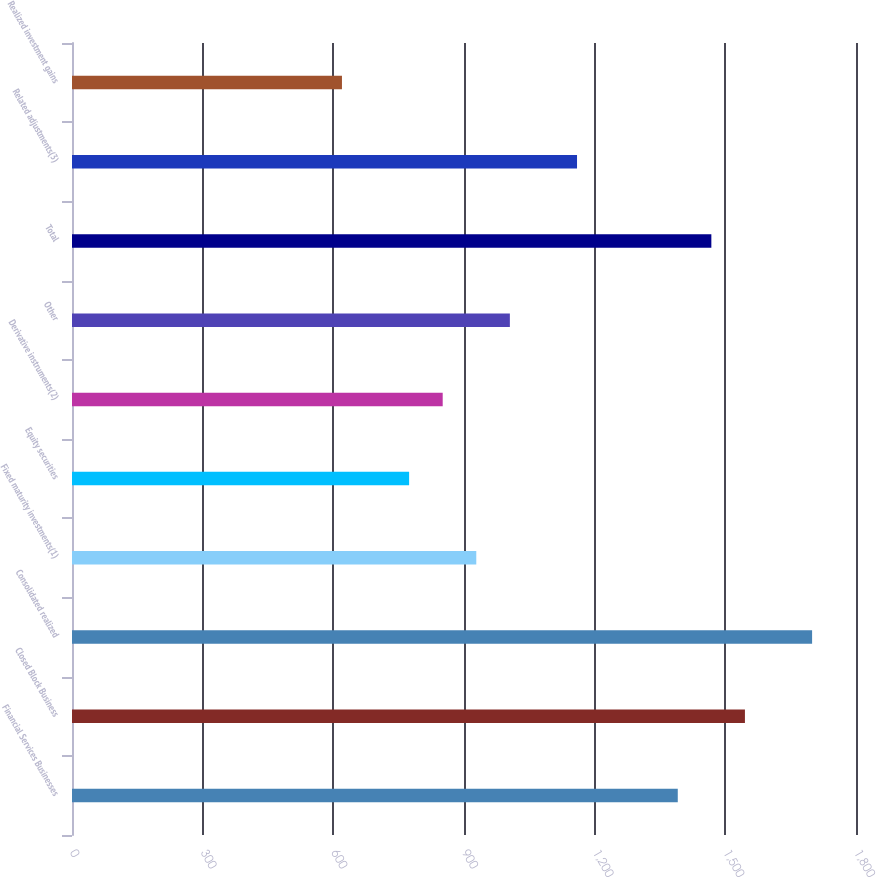Convert chart to OTSL. <chart><loc_0><loc_0><loc_500><loc_500><bar_chart><fcel>Financial Services Businesses<fcel>Closed Block Business<fcel>Consolidated realized<fcel>Fixed maturity investments(1)<fcel>Equity securities<fcel>Derivative instruments(2)<fcel>Other<fcel>Total<fcel>Related adjustments(3)<fcel>Realized investment gains<nl><fcel>1390.8<fcel>1545<fcel>1699.2<fcel>928.2<fcel>774<fcel>851.1<fcel>1005.3<fcel>1467.9<fcel>1159.5<fcel>619.8<nl></chart> 